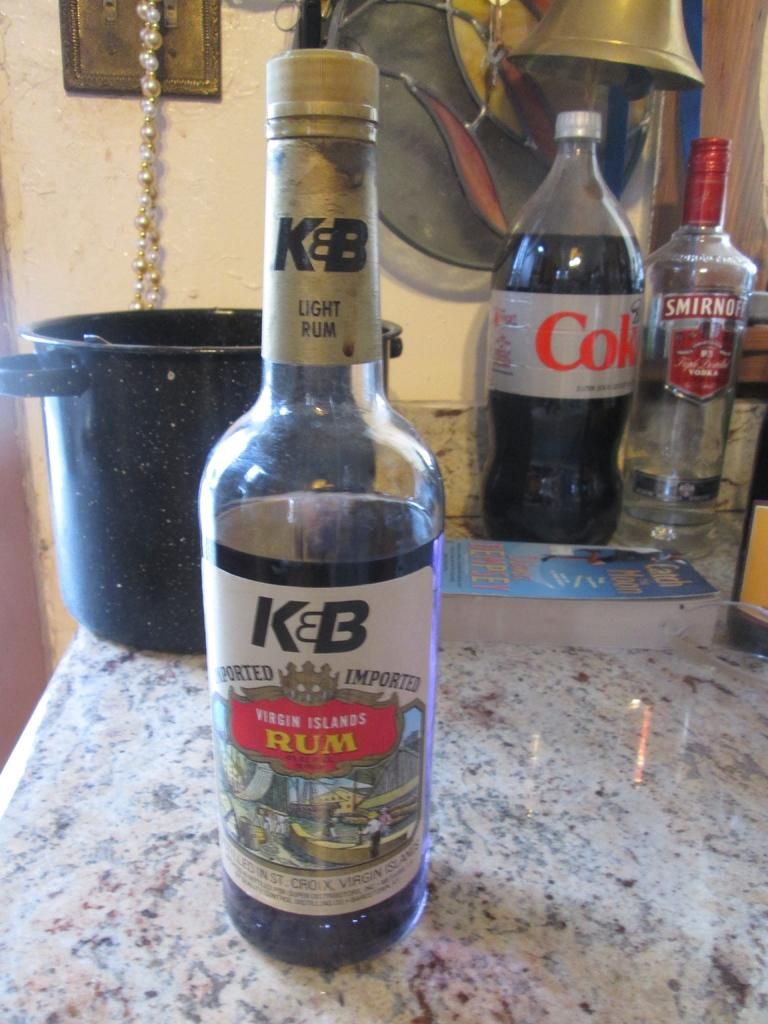<image>
Summarize the visual content of the image. Alcohol bottle for KEB on top of a marble counter. 